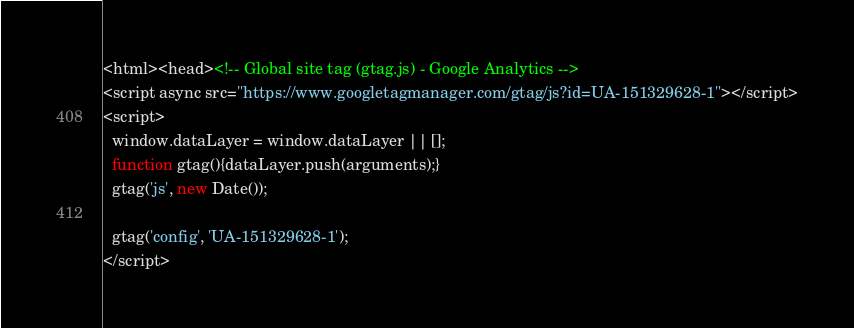<code> <loc_0><loc_0><loc_500><loc_500><_HTML_><html><head><!-- Global site tag (gtag.js) - Google Analytics -->
<script async src="https://www.googletagmanager.com/gtag/js?id=UA-151329628-1"></script>
<script>
  window.dataLayer = window.dataLayer || [];
  function gtag(){dataLayer.push(arguments);}
  gtag('js', new Date());

  gtag('config', 'UA-151329628-1');
</script></code> 